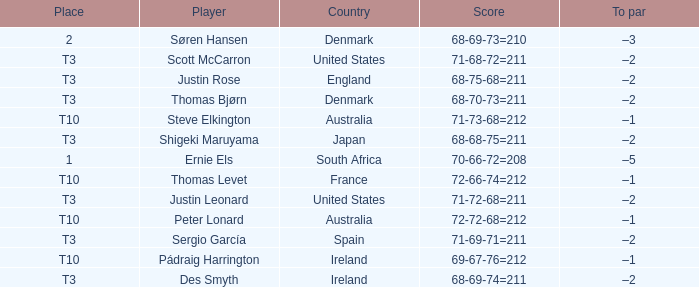What was the place when the score was 68-75-68=211? T3. 